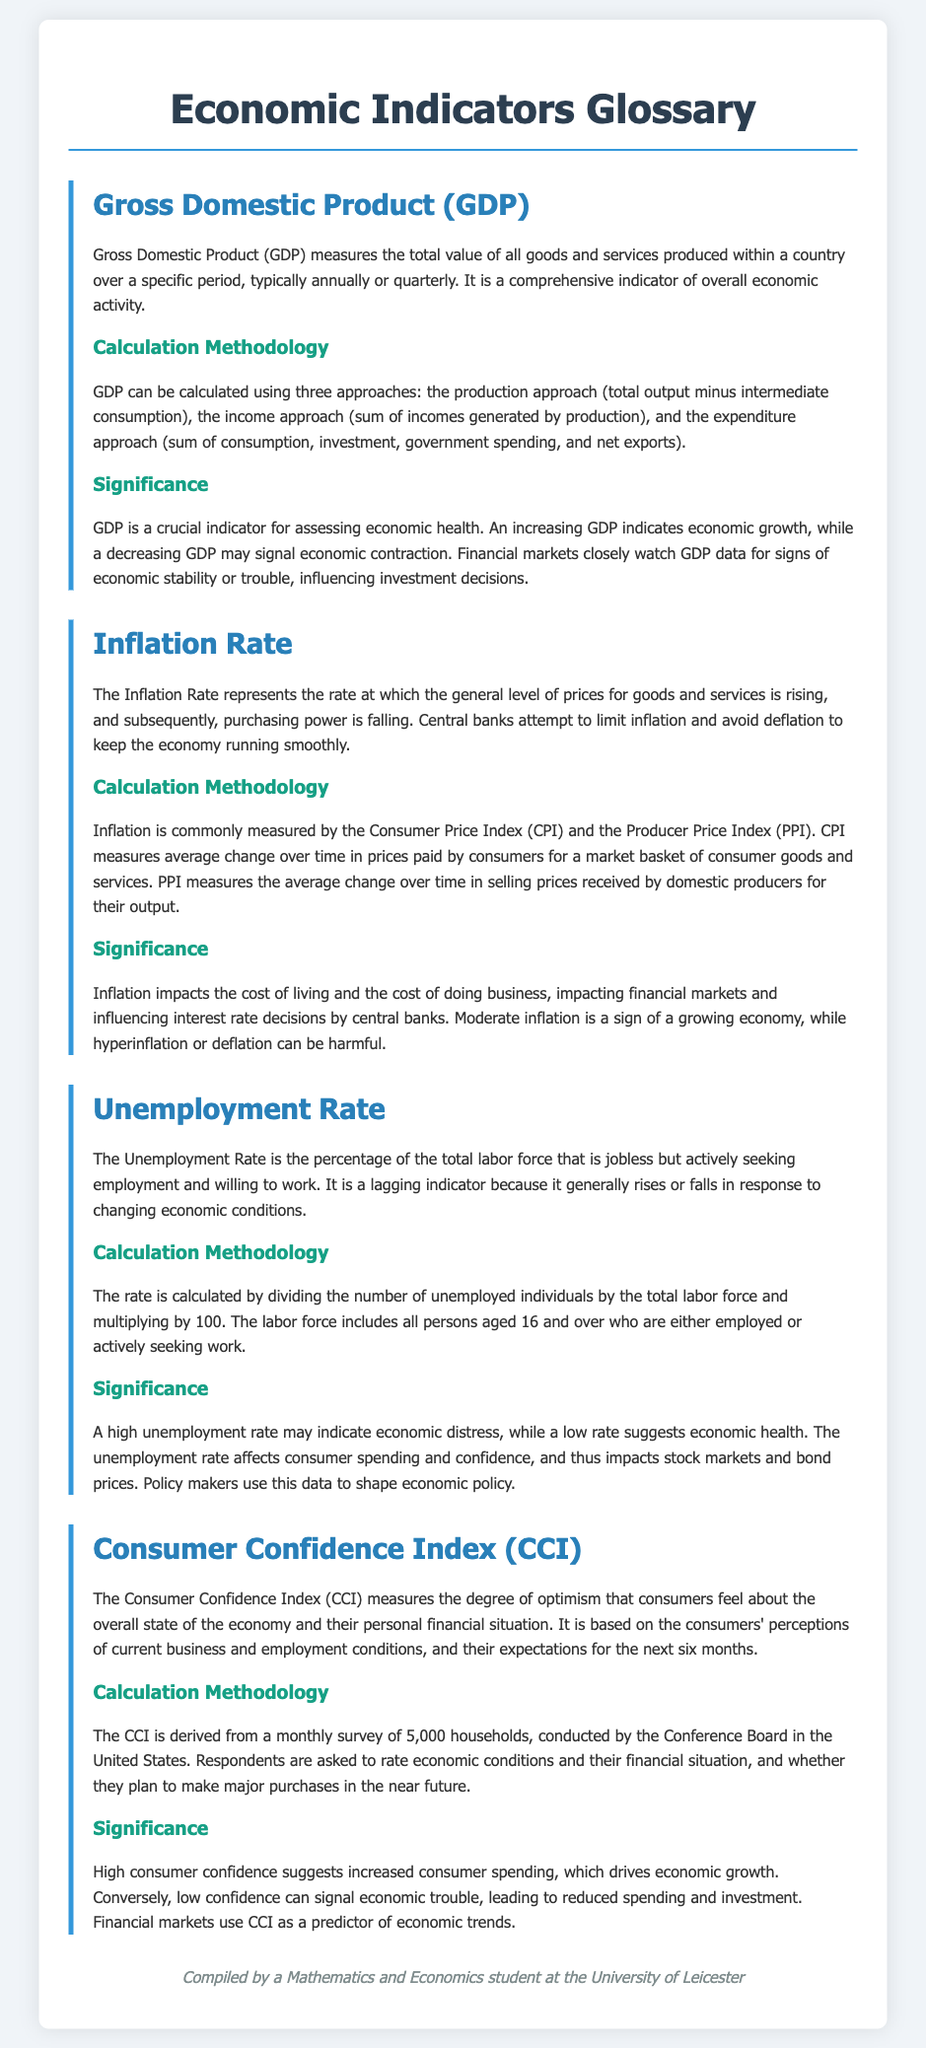What does GDP stand for? GDP stands for Gross Domestic Product, which measures the total value of all goods and services produced within a country.
Answer: Gross Domestic Product What does the Inflation Rate represent? The Inflation Rate represents the rate at which the general level of prices for goods and services is rising, leading to a fall in purchasing power.
Answer: The rate of price increase How is the Unemployment Rate calculated? The Unemployment Rate is calculated by dividing the number of unemployed individuals by the total labor force and multiplying by 100.
Answer: (Unemployed / Labor Force) * 100 What is a lagging indicator? A lagging indicator is a measurement that responds after the economy has already begun to change, such as the Unemployment Rate.
Answer: Unemployment Rate What does a high Consumer Confidence Index indicate? A high Consumer Confidence Index suggests increased consumer spending, which drives economic growth.
Answer: Increased consumer spending What three approaches can be used to calculate GDP? The three approaches are production, income, and expenditure approaches.
Answer: Production, income, and expenditure What does CPI stand for? CPI stands for Consumer Price Index, which measures average changes in prices paid by consumers for a market basket of goods and services.
Answer: Consumer Price Index What impacts financial markets and influences interest rate decisions? Inflation impacts the cost of living and the cost of doing business, which affects financial markets and interest rate decisions.
Answer: Inflation Which index measures consumer optimism regarding the economy? The Consumer Confidence Index (CCI) measures consumers' optimism about the overall state of the economy.
Answer: Consumer Confidence Index 